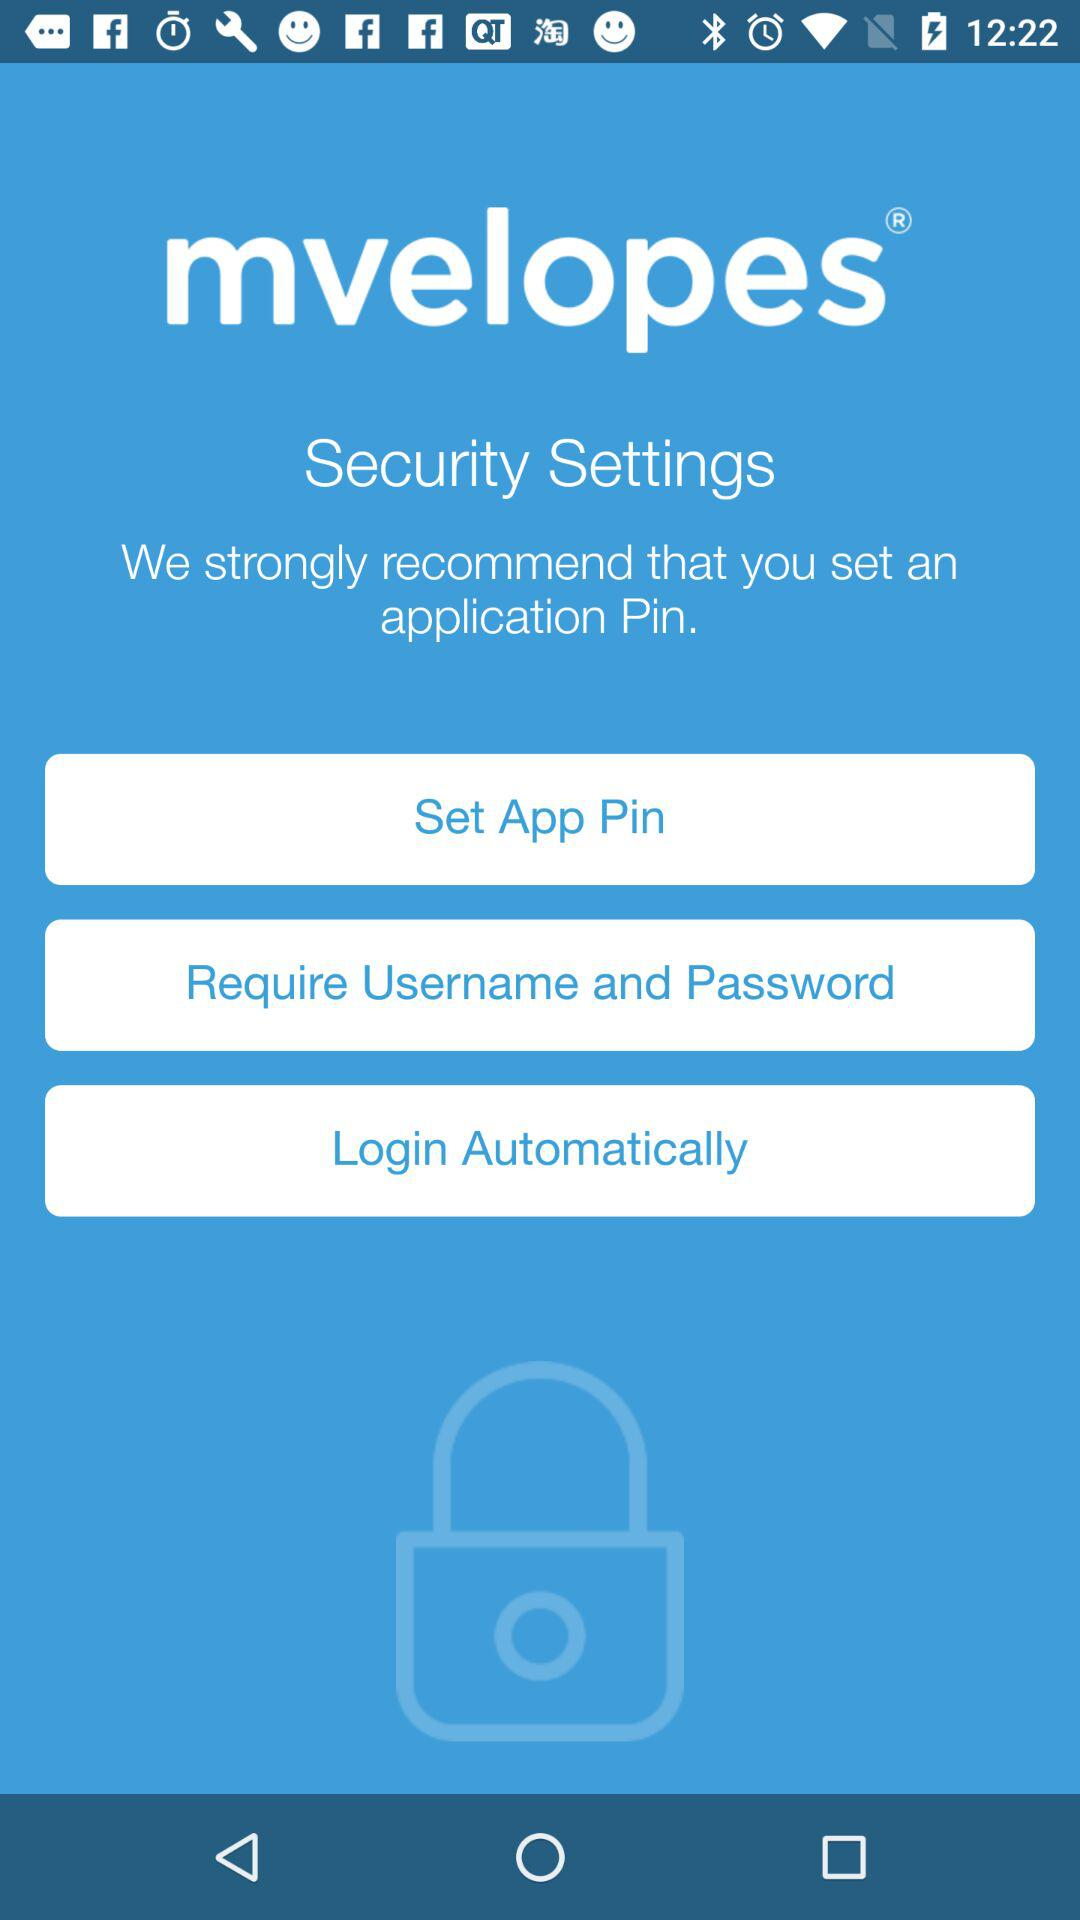What is the name of the application? The name of the application is "mvelopes". 